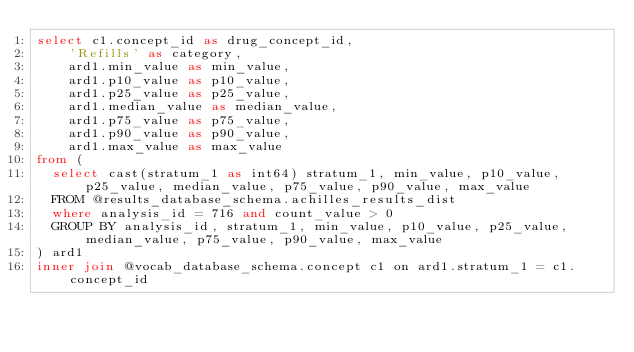Convert code to text. <code><loc_0><loc_0><loc_500><loc_500><_SQL_>select c1.concept_id as drug_concept_id,
	'Refills' as category,
	ard1.min_value as min_value,
	ard1.p10_value as p10_value,
	ard1.p25_value as p25_value,
	ard1.median_value as median_value,
	ard1.p75_value as p75_value,
	ard1.p90_value as p90_value,
	ard1.max_value as max_value
from (
  select cast(stratum_1 as int64) stratum_1, min_value, p10_value, p25_value, median_value, p75_value, p90_value, max_value
  FROM @results_database_schema.achilles_results_dist
  where analysis_id = 716 and count_value > 0
  GROUP BY analysis_id, stratum_1, min_value, p10_value, p25_value, median_value, p75_value, p90_value, max_value 
) ard1
inner join @vocab_database_schema.concept c1 on ard1.stratum_1 = c1.concept_id
</code> 